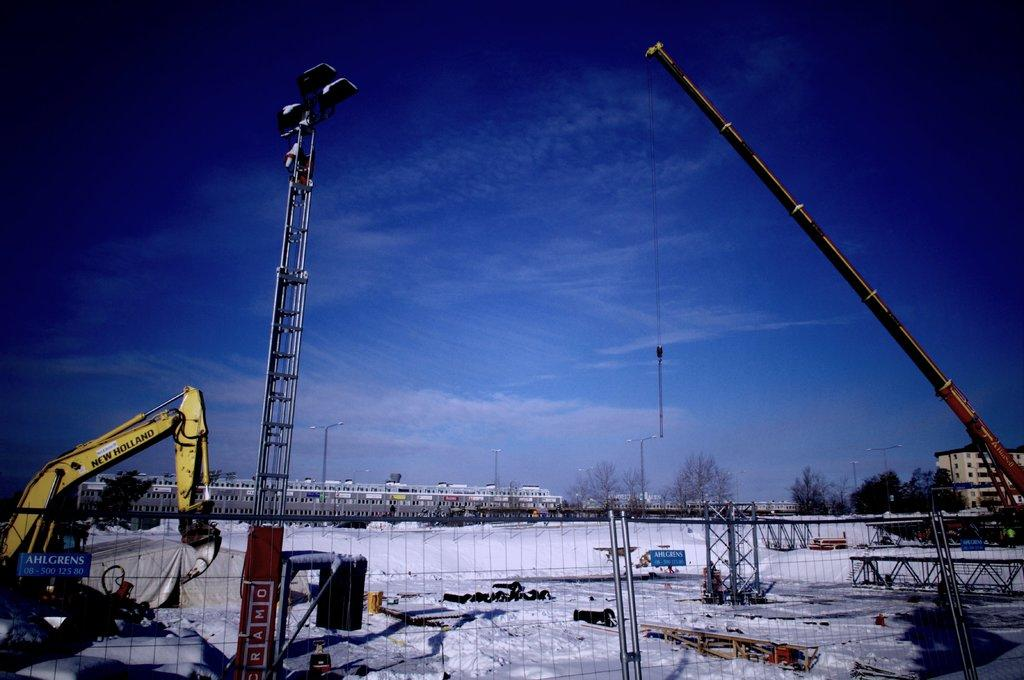What types of man-made structures can be seen in the image? There are vehicles, a fence, poles, street lights, and buildings visible in the image. What natural elements are present in the image? There are trees and the sky visible in the image. What other objects can be seen in the image? There are other objects in the image, but their specific nature is not mentioned in the provided facts. Can you see a cobweb hanging from the street light in the image? There is no mention of a cobweb in the provided facts, so it cannot be determined if one is present in the image. Is the road in the image sloping downwards? The provided facts do not mention the slope of the road, so it cannot be determined from the image. 